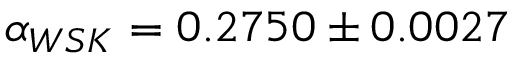Convert formula to latex. <formula><loc_0><loc_0><loc_500><loc_500>\alpha _ { W S K } = 0 . 2 7 5 0 \pm 0 . 0 0 2 7</formula> 